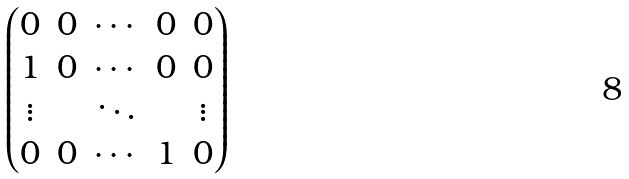<formula> <loc_0><loc_0><loc_500><loc_500>\begin{pmatrix} 0 & 0 & \cdots & 0 & 0 \\ 1 & 0 & \cdots & 0 & 0 \\ \vdots & & \ddots & & \vdots \\ 0 & 0 & \cdots & 1 & 0 \end{pmatrix}</formula> 